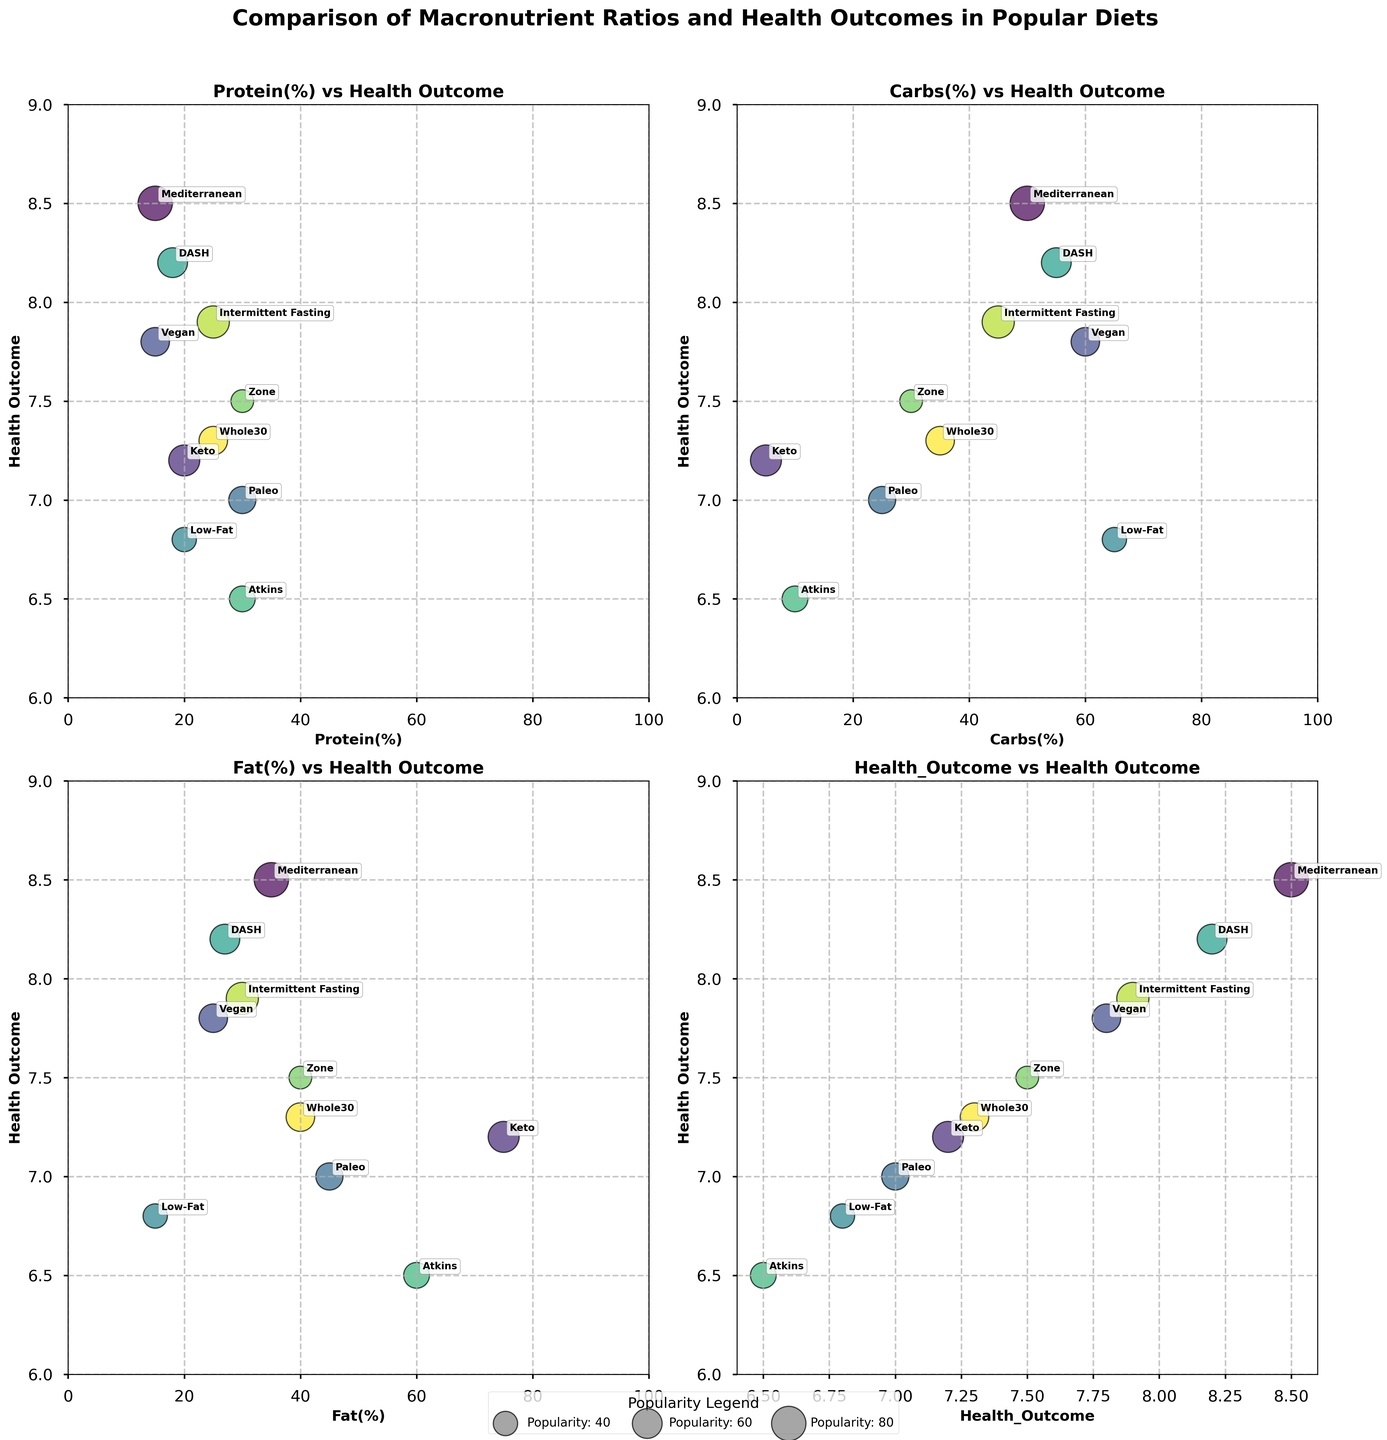What's the title of the figure? The title of the figure is written in bold at the top of the entire subplot. The title reads: "Comparison of Macronutrient Ratios and Health Outcomes in Popular Diets."
Answer: Comparison of Macronutrient Ratios and Health Outcomes in Popular Diets Which diet has the highest health outcome? Look at the y-axis labeled "Health Outcome" in any subplot, and find the highest point. The annotated diet at this position indicates the highest health outcome. The diet annotated at the highest position (8.5) is "Mediterranean."
Answer: Mediterranean What are the macronutrient ratios (Protein, Carbs, and Fat) of the diet with the lowest health outcome? First, identify the diet with the lowest health outcome which is 6.5 in any subplot. Follow the annotations to find the diet name (Atkins) and then refer to its corresponding data for macronutrient ratios: Protein (30%), Carbs (10%), and Fat (60%).
Answer: Protein: 30%, Carbs: 10%, Fat: 60% Which diet has the highest popularity? Locate the largest bubbles in any subplot; the largest bubble signifies the highest popularity. The annotated diet by the largest bubble is "Mediterranean."
Answer: Mediterranean Compare the health outcomes of Keto and Paleo. Which one is higher? Locate both diets by their annotations on the y-axis labeled "Health Outcome." Keto has a health outcome of 7.2 while Paleo has 7.0. Therefore, Keto's health outcome is higher.
Answer: Keto Which diet appears to have a balanced macronutrient distribution based on the scatter plots? A balanced macronutrient distribution can be inferred from near-equal values in Protein, Carbs, and Fat axes. The "Zone" diet, with 30% Protein, 30% Carbs, and 40% Fat, is nearest to balanced distribution.
Answer: Zone How do the popularity sizes of Low-Fat and DASH diets compare? Look at the size of the bubbles representing Low-Fat and DASH in any subplot. The DASH diet has a moderately large bubble indicating a popularity of 60, while Low-Fat has a smaller bubble indicating a popularity of 40. Thus, DASH is more popular than Low-Fat.
Answer: DASH is more popular In the subplot comparing Carbs(%) and Health Outcome, which diet has the highest percentage of Carbs? Find the highest x-axis value labeled "Carbs(%)" in the plot with Carbs(%) and Health Outcome. The highest annotated value of 65% belongs to the "Low-Fat" diet.
Answer: Low-Fat What is the range of health outcomes provided in the figure? Review the y-axis labeled "Health Outcome" across all subplots and find the minimum and maximum values annotated. The range spans from 6.5 (Atkins diet) to 8.5 (Mediterranean diet).
Answer: 6.5 to 8.5 